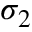Convert formula to latex. <formula><loc_0><loc_0><loc_500><loc_500>\sigma _ { 2 }</formula> 